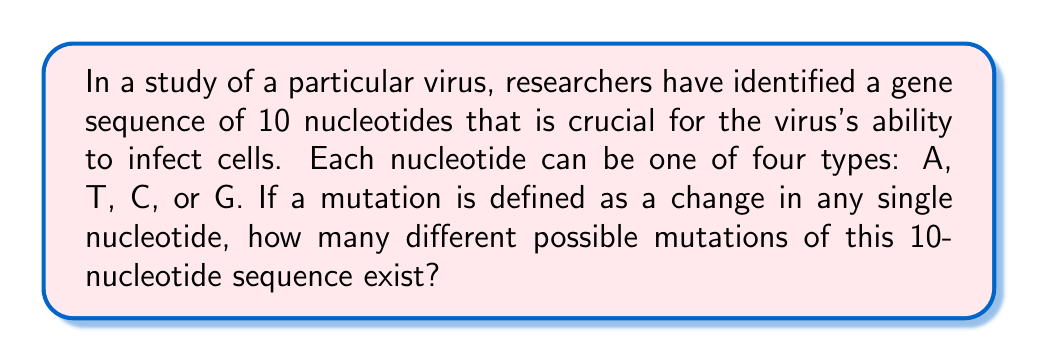Solve this math problem. To solve this problem, we need to use the concept of permutations with repetition. Let's break it down step-by-step:

1) First, we need to understand what constitutes a mutation. In this case, a mutation is a change in any single nucleotide in the 10-nucleotide sequence.

2) For each position in the sequence, there are 3 possible mutations (changing to one of the other 3 nucleotides), and there are 10 positions where a mutation can occur.

3) We can use the multiplication principle of counting here. The total number of mutations will be the sum of mutations possible at each position.

4) At each position:
   - There are 3 possible mutations
   - There are 10 positions

5) Therefore, the total number of possible mutations is:

   $$ \text{Total mutations} = 10 \times 3 = 30 $$

This can also be thought of as a permutation problem where we are selecting 1 position out of 10 to mutate ($$\binom{10}{1}$$) and then choosing 1 out of 3 possible new nucleotides for that position:

$$ \text{Total mutations} = \binom{10}{1} \times 3 = 10 \times 3 = 30 $$
Answer: 30 possible mutations 